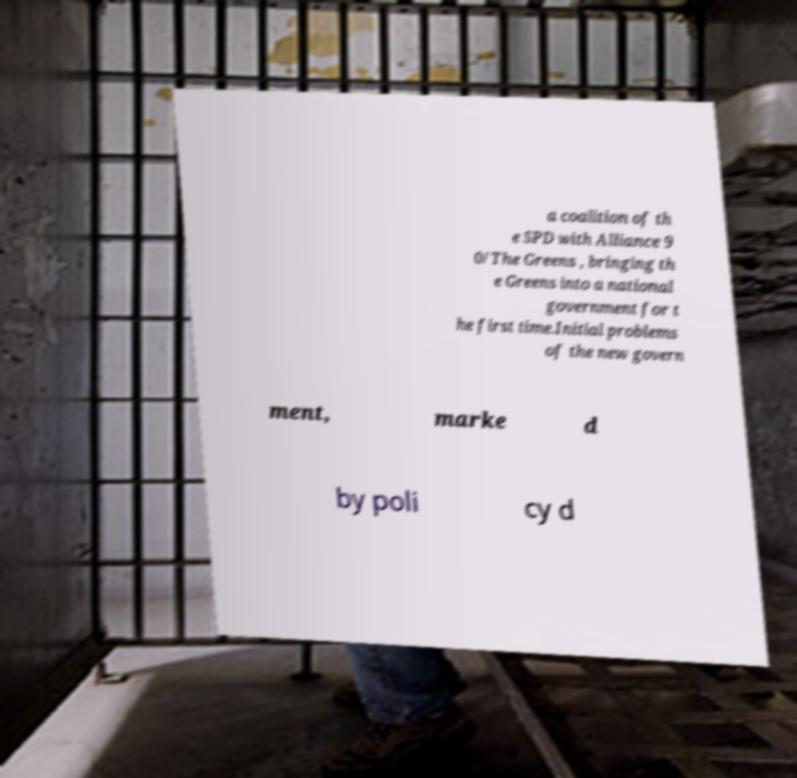For documentation purposes, I need the text within this image transcribed. Could you provide that? a coalition of th e SPD with Alliance 9 0/The Greens , bringing th e Greens into a national government for t he first time.Initial problems of the new govern ment, marke d by poli cy d 